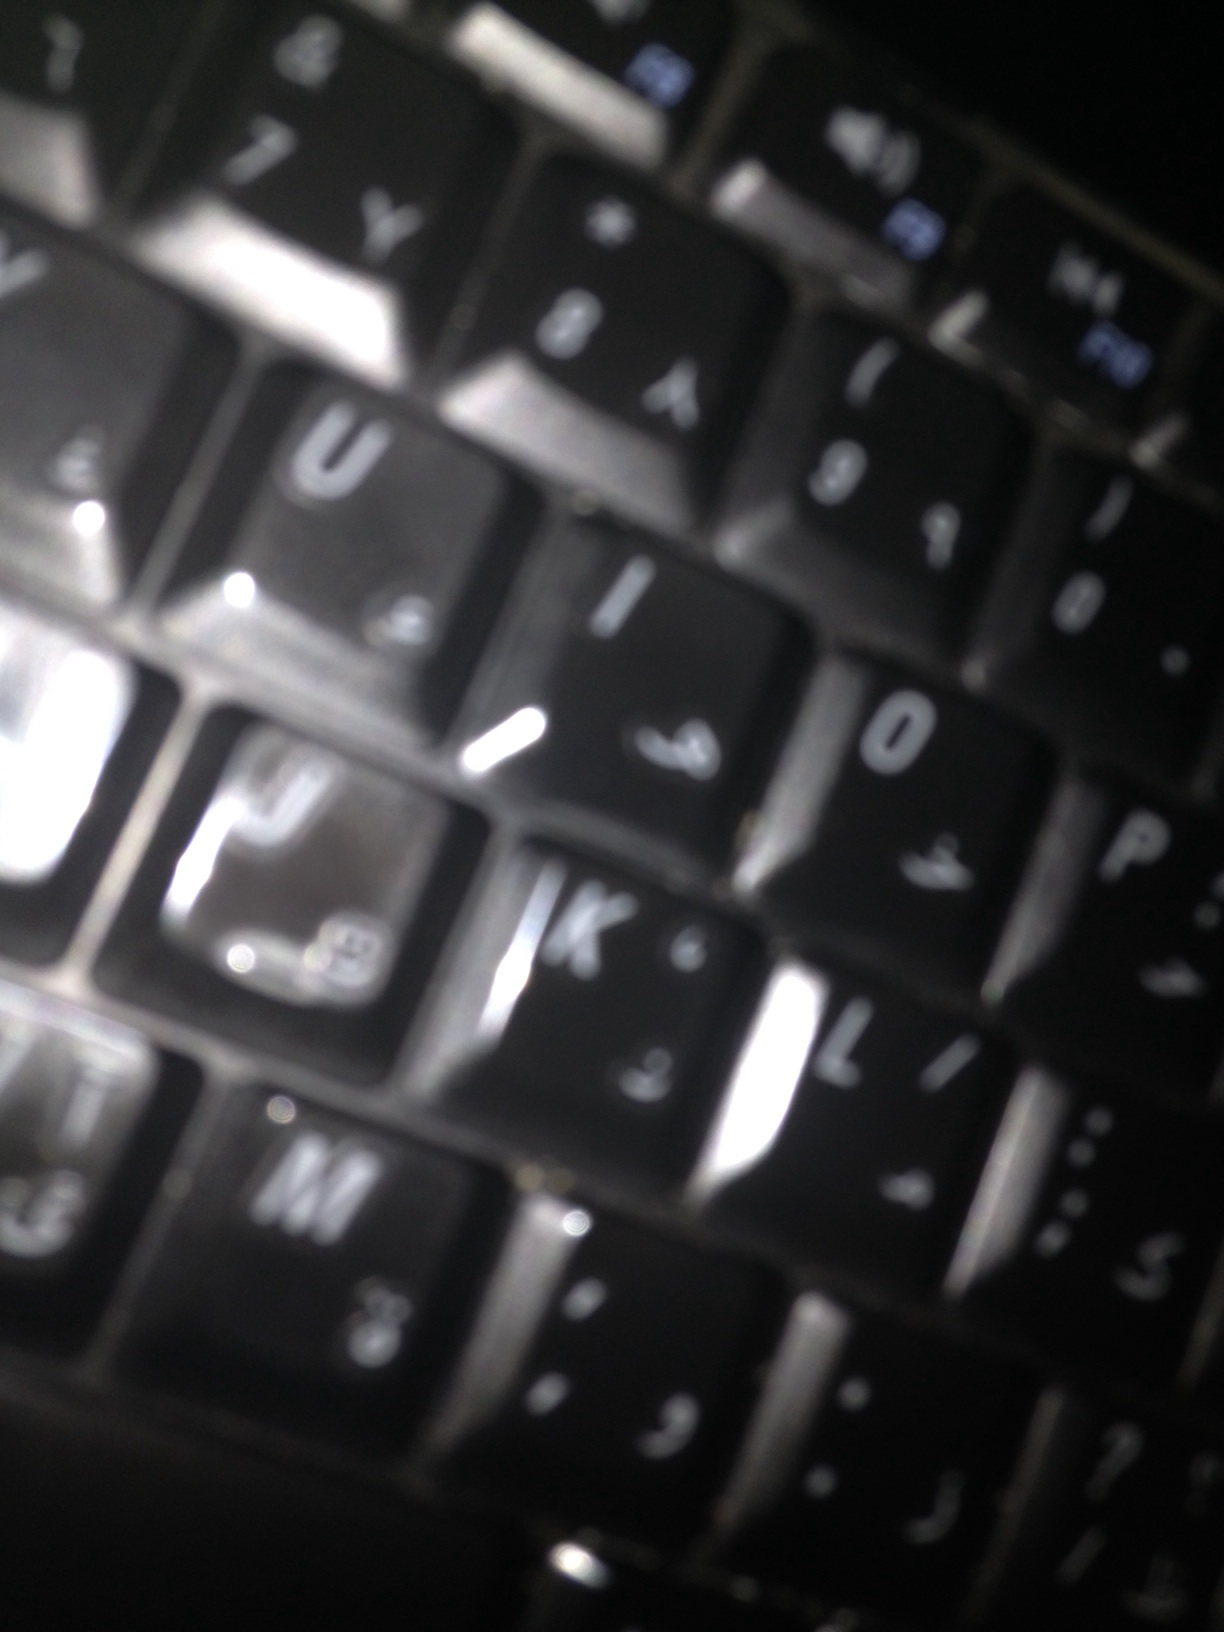What can you infer about the language used on this keyboard? The keyboard appears to have keys with both English and Arabic letters. This suggests that the user might be bilingual or operates in an environment where both languages are commonly used. Do you think this keyboard belongs to a person in a specific profession? It's possible that this keyboard belongs to someone who needs to type in multiple languages, such as a translator, an international business professional, or perhaps a linguist. 